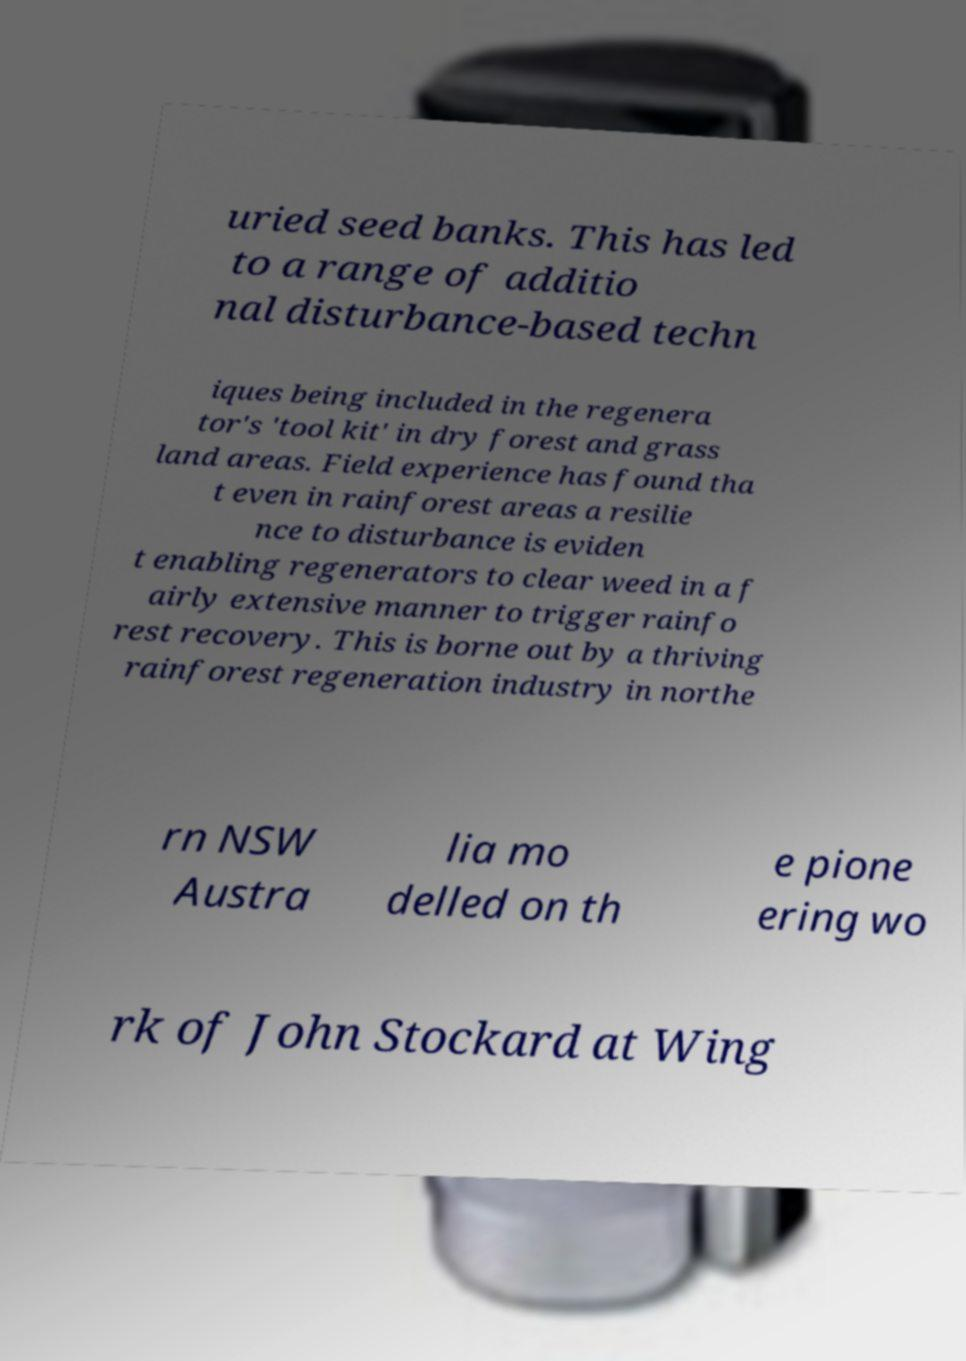Please identify and transcribe the text found in this image. uried seed banks. This has led to a range of additio nal disturbance-based techn iques being included in the regenera tor's 'tool kit' in dry forest and grass land areas. Field experience has found tha t even in rainforest areas a resilie nce to disturbance is eviden t enabling regenerators to clear weed in a f airly extensive manner to trigger rainfo rest recovery. This is borne out by a thriving rainforest regeneration industry in northe rn NSW Austra lia mo delled on th e pione ering wo rk of John Stockard at Wing 